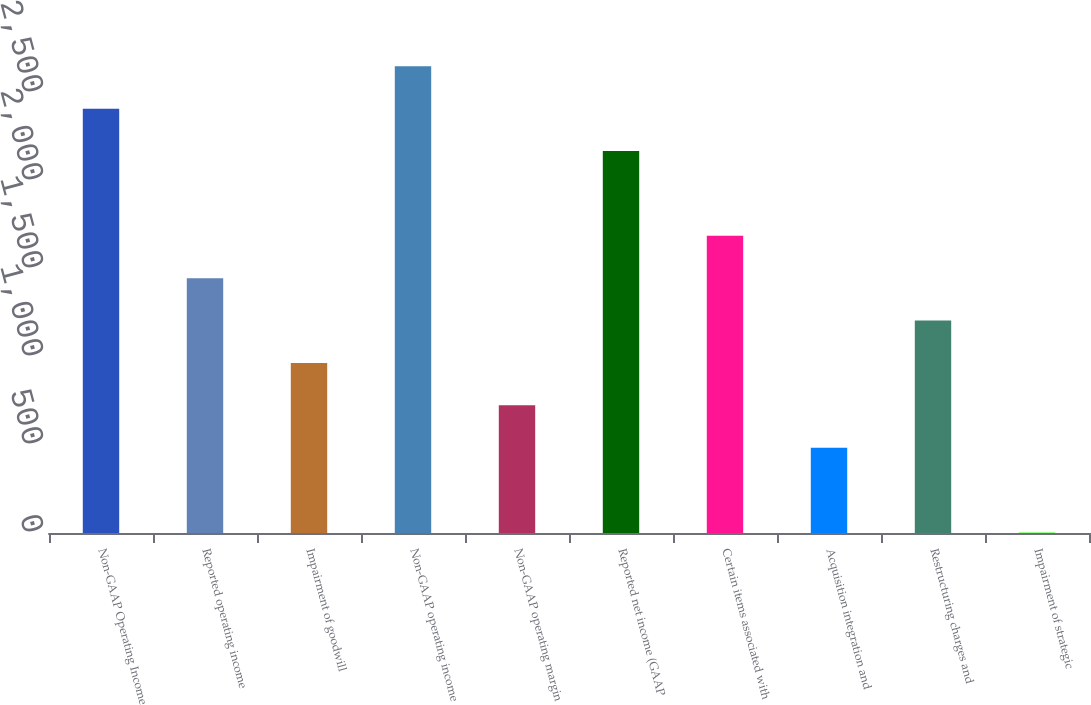<chart> <loc_0><loc_0><loc_500><loc_500><bar_chart><fcel>Non-GAAP Operating Income<fcel>Reported operating income<fcel>Impairment of goodwill<fcel>Non-GAAP operating income<fcel>Non-GAAP operating margin<fcel>Reported net income (GAAP<fcel>Certain items associated with<fcel>Acquisition integration and<fcel>Restructuring charges and<fcel>Impairment of strategic<nl><fcel>2411<fcel>1447.8<fcel>966.2<fcel>2651.8<fcel>725.4<fcel>2170.2<fcel>1688.6<fcel>484.6<fcel>1207<fcel>3<nl></chart> 